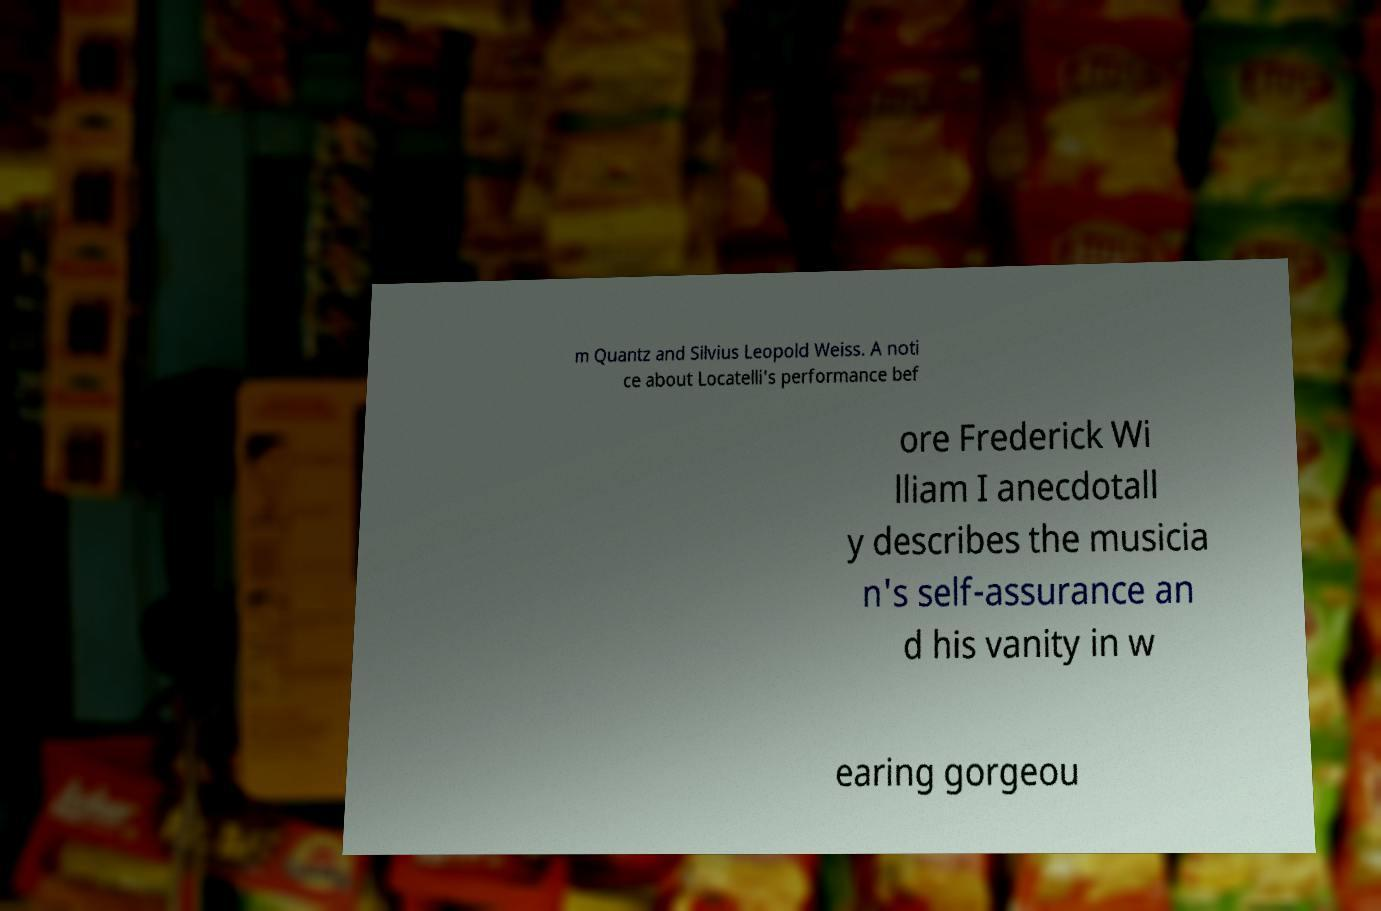Can you read and provide the text displayed in the image?This photo seems to have some interesting text. Can you extract and type it out for me? m Quantz and Silvius Leopold Weiss. A noti ce about Locatelli's performance bef ore Frederick Wi lliam I anecdotall y describes the musicia n's self-assurance an d his vanity in w earing gorgeou 